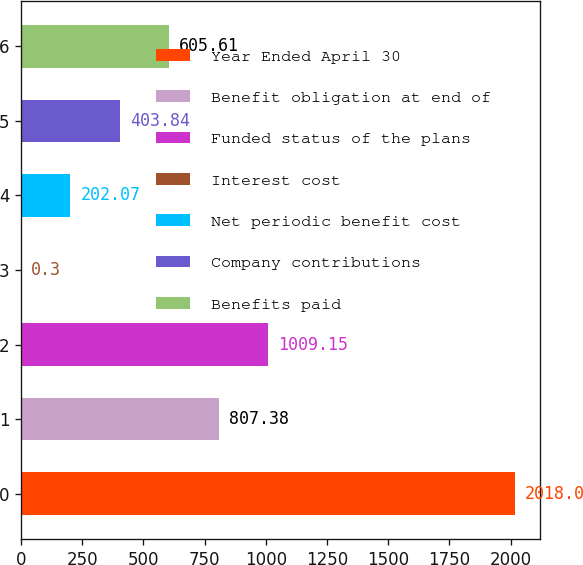Convert chart to OTSL. <chart><loc_0><loc_0><loc_500><loc_500><bar_chart><fcel>Year Ended April 30<fcel>Benefit obligation at end of<fcel>Funded status of the plans<fcel>Interest cost<fcel>Net periodic benefit cost<fcel>Company contributions<fcel>Benefits paid<nl><fcel>2018<fcel>807.38<fcel>1009.15<fcel>0.3<fcel>202.07<fcel>403.84<fcel>605.61<nl></chart> 